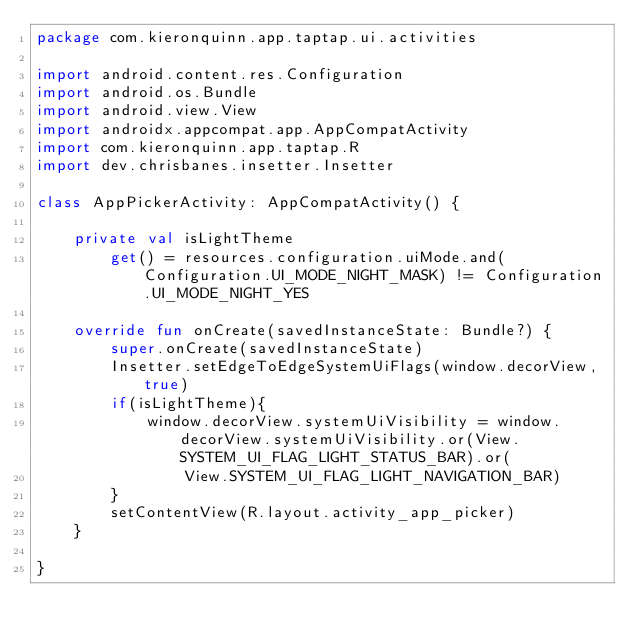<code> <loc_0><loc_0><loc_500><loc_500><_Kotlin_>package com.kieronquinn.app.taptap.ui.activities

import android.content.res.Configuration
import android.os.Bundle
import android.view.View
import androidx.appcompat.app.AppCompatActivity
import com.kieronquinn.app.taptap.R
import dev.chrisbanes.insetter.Insetter

class AppPickerActivity: AppCompatActivity() {

    private val isLightTheme
        get() = resources.configuration.uiMode.and(Configuration.UI_MODE_NIGHT_MASK) != Configuration.UI_MODE_NIGHT_YES

    override fun onCreate(savedInstanceState: Bundle?) {
        super.onCreate(savedInstanceState)
        Insetter.setEdgeToEdgeSystemUiFlags(window.decorView, true)
        if(isLightTheme){
            window.decorView.systemUiVisibility = window.decorView.systemUiVisibility.or(View.SYSTEM_UI_FLAG_LIGHT_STATUS_BAR).or(
                View.SYSTEM_UI_FLAG_LIGHT_NAVIGATION_BAR)
        }
        setContentView(R.layout.activity_app_picker)
    }

}</code> 